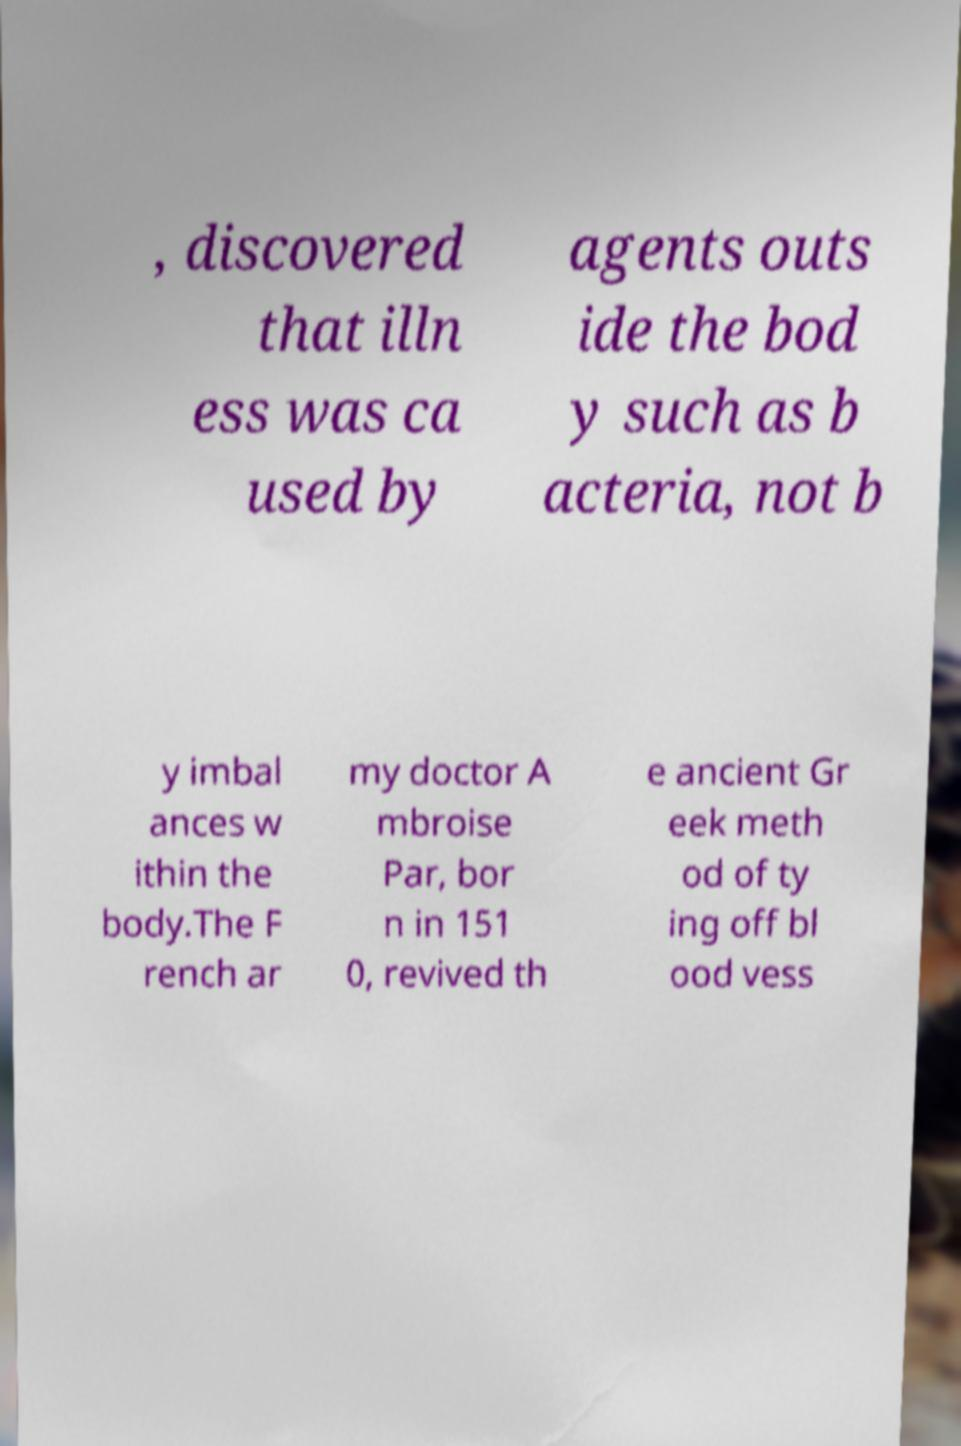What messages or text are displayed in this image? I need them in a readable, typed format. , discovered that illn ess was ca used by agents outs ide the bod y such as b acteria, not b y imbal ances w ithin the body.The F rench ar my doctor A mbroise Par, bor n in 151 0, revived th e ancient Gr eek meth od of ty ing off bl ood vess 